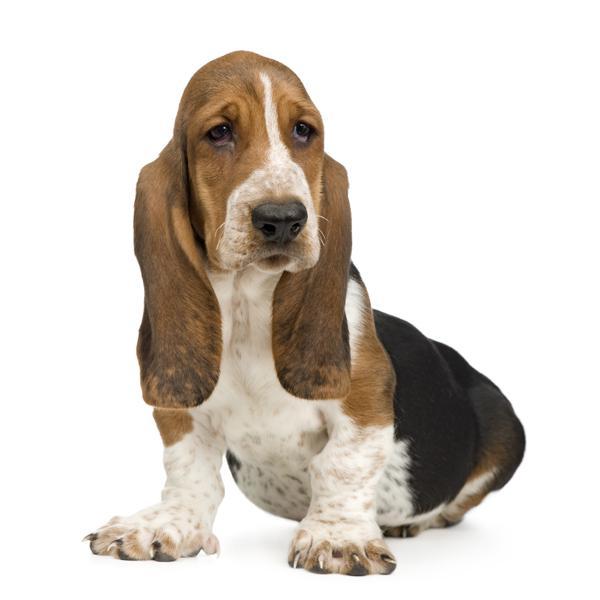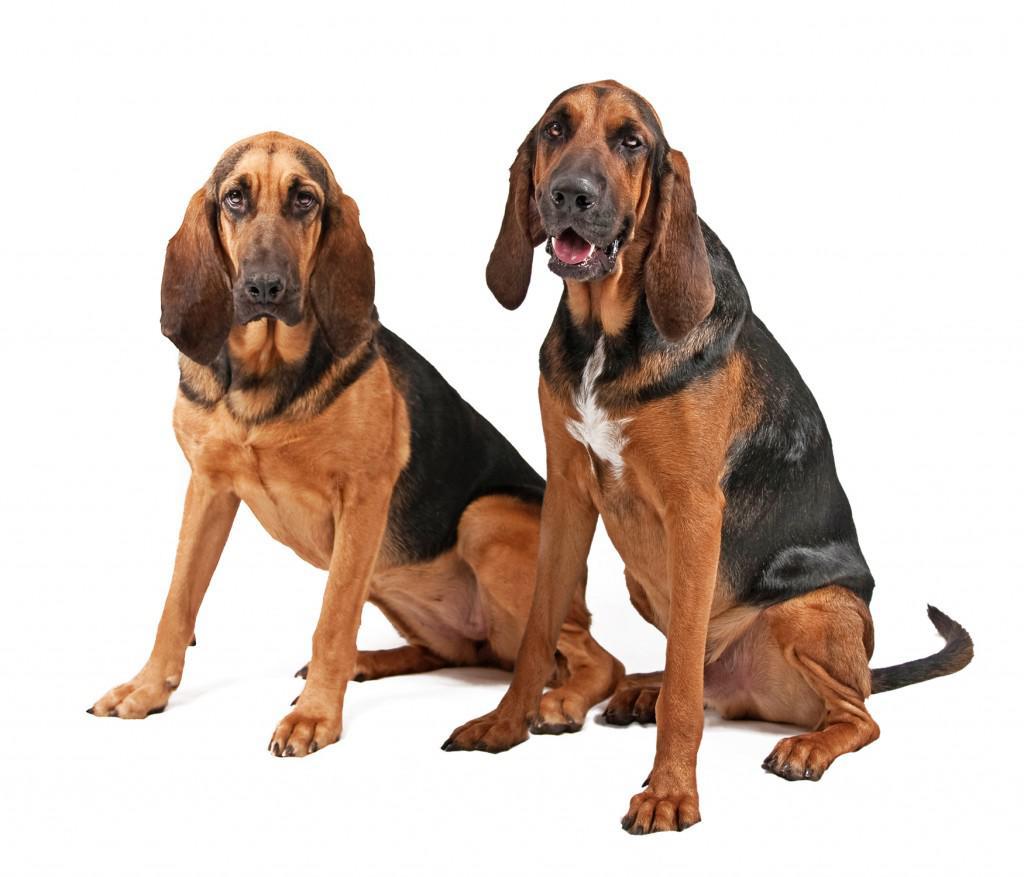The first image is the image on the left, the second image is the image on the right. For the images shown, is this caption "There are at least two dogs in the image on the right." true? Answer yes or no. Yes. 